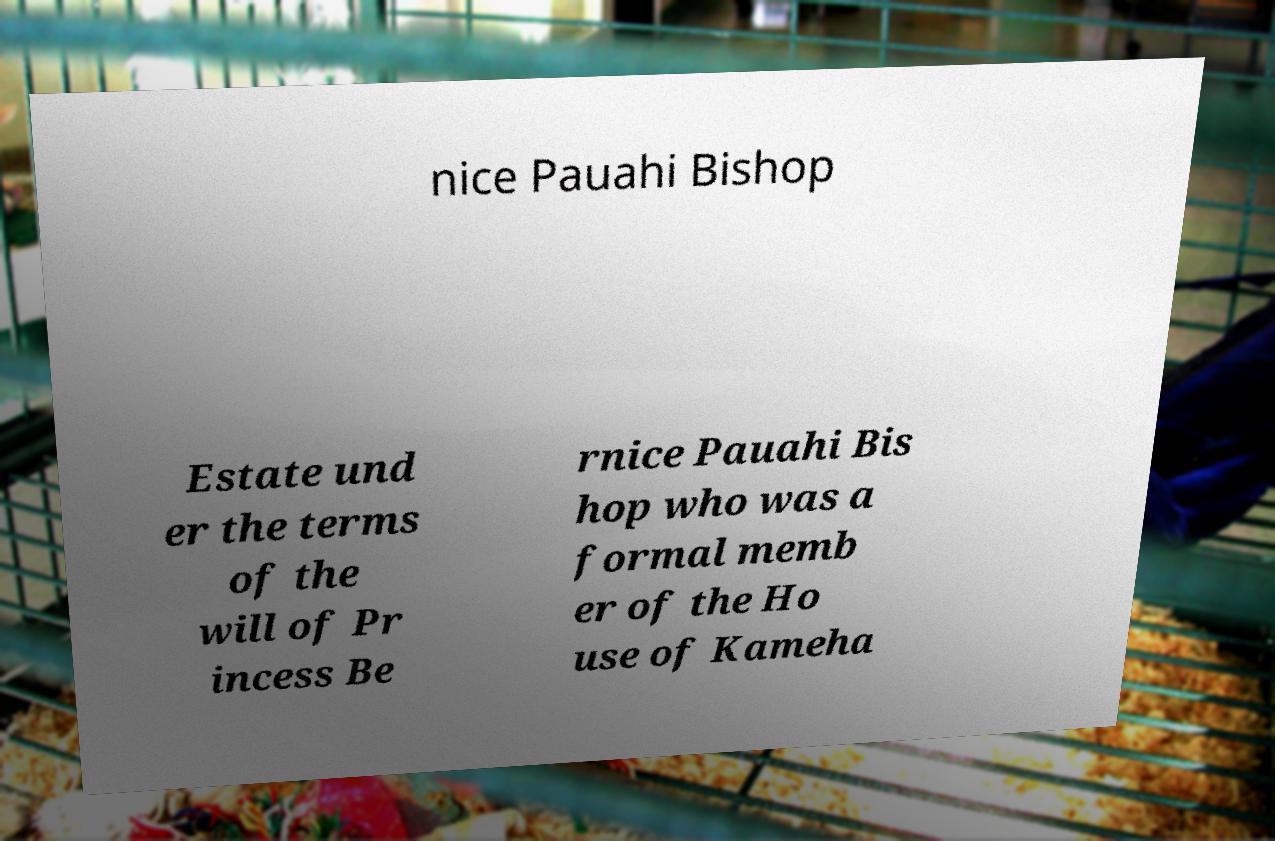There's text embedded in this image that I need extracted. Can you transcribe it verbatim? nice Pauahi Bishop Estate und er the terms of the will of Pr incess Be rnice Pauahi Bis hop who was a formal memb er of the Ho use of Kameha 